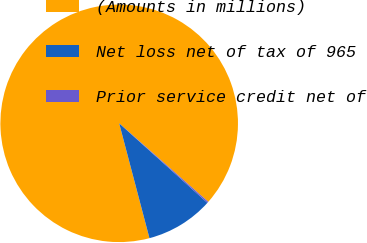<chart> <loc_0><loc_0><loc_500><loc_500><pie_chart><fcel>(Amounts in millions)<fcel>Net loss net of tax of 965<fcel>Prior service credit net of<nl><fcel>90.6%<fcel>9.22%<fcel>0.18%<nl></chart> 